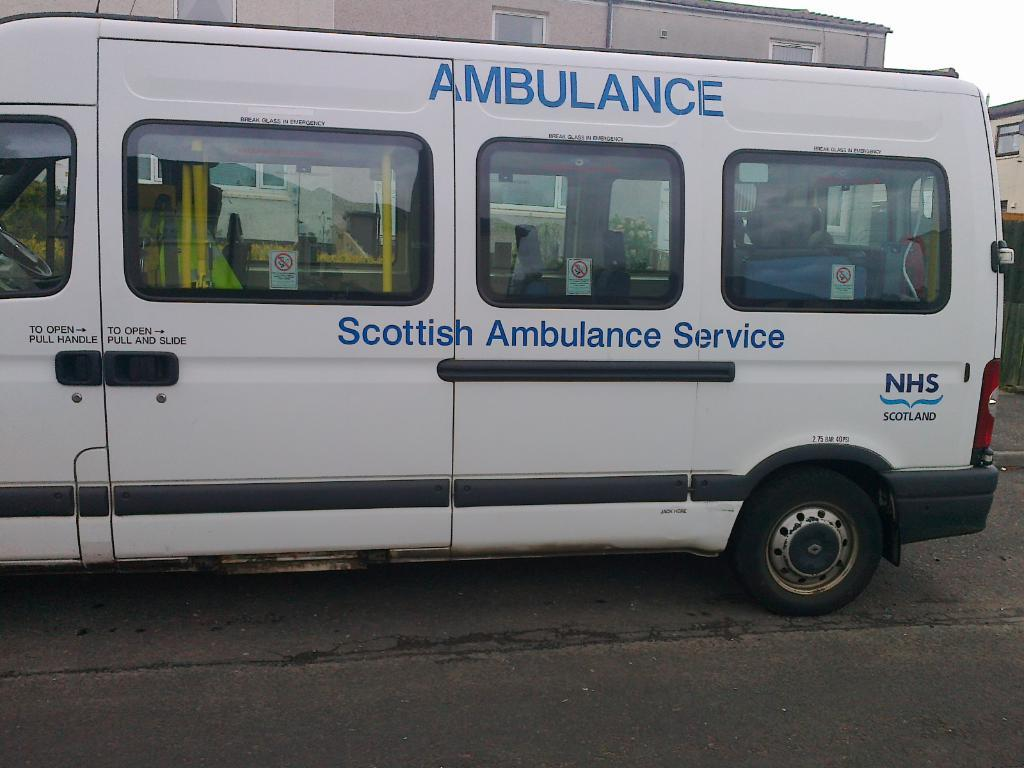<image>
Share a concise interpretation of the image provided. A white Ambulance from Scottish Ambulance Service sits on the road 